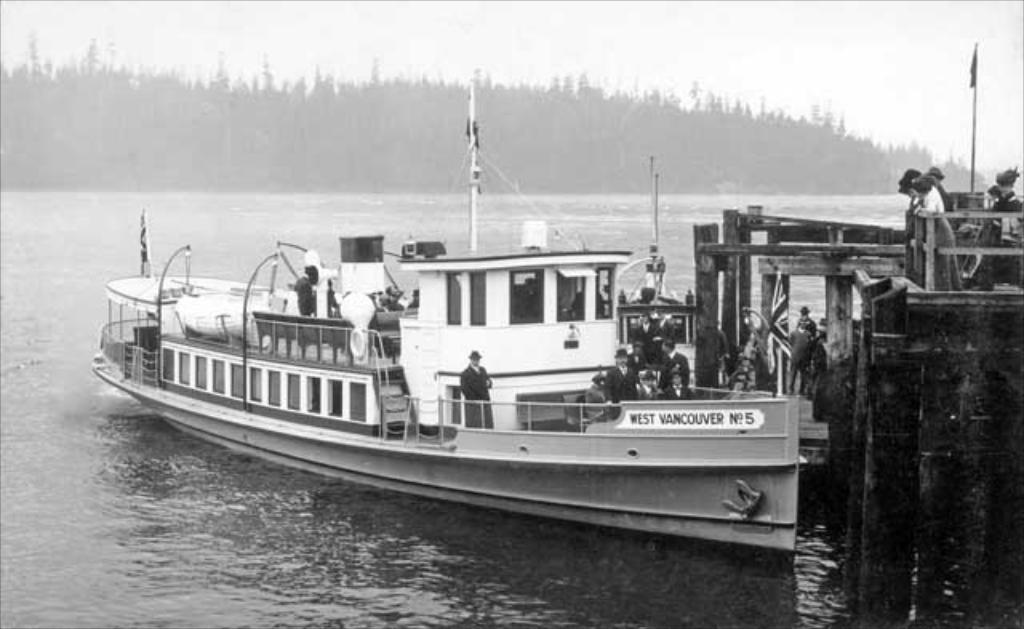<image>
Describe the image concisely. People standing on a ship which says "West Vancouver" on it. 